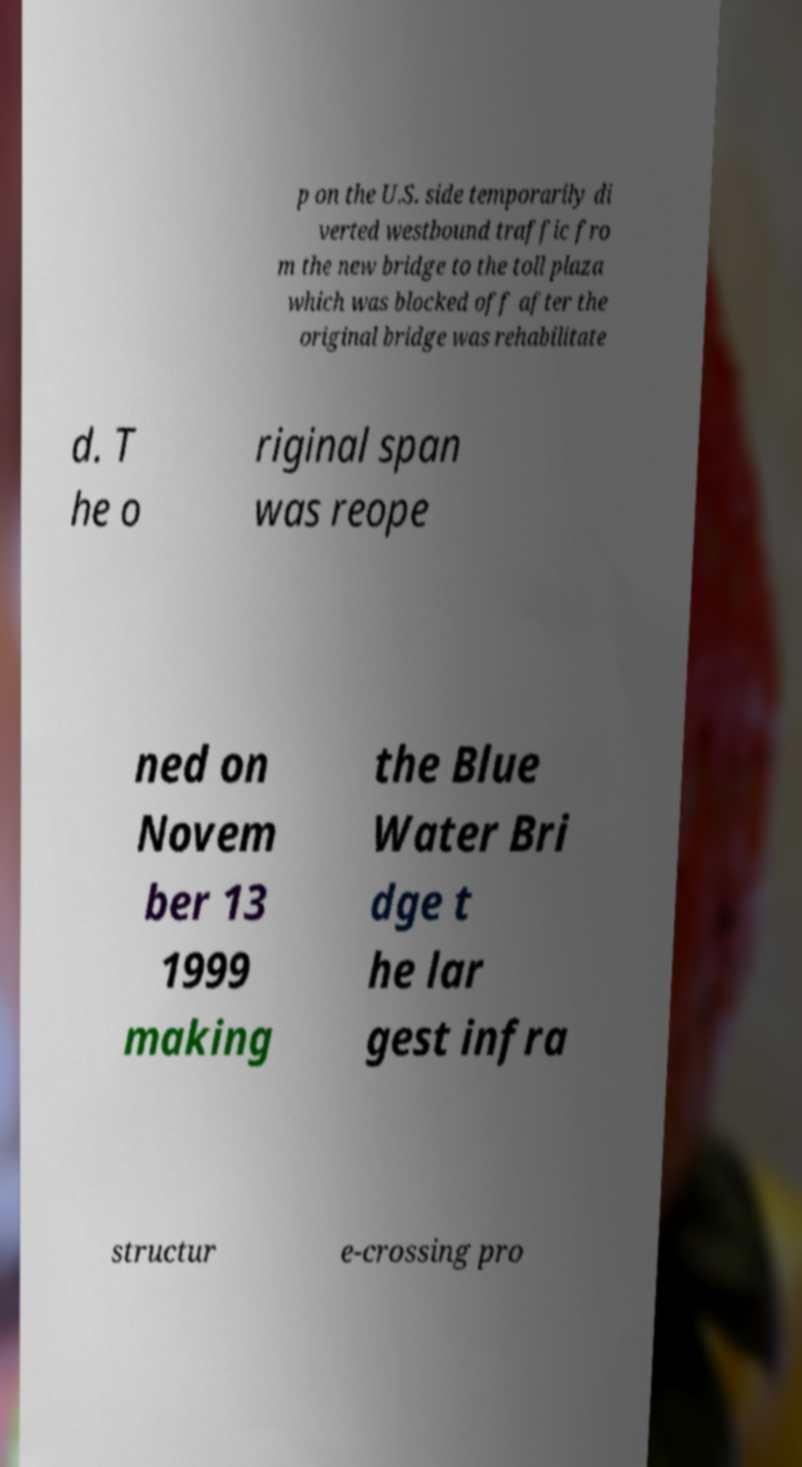I need the written content from this picture converted into text. Can you do that? p on the U.S. side temporarily di verted westbound traffic fro m the new bridge to the toll plaza which was blocked off after the original bridge was rehabilitate d. T he o riginal span was reope ned on Novem ber 13 1999 making the Blue Water Bri dge t he lar gest infra structur e-crossing pro 